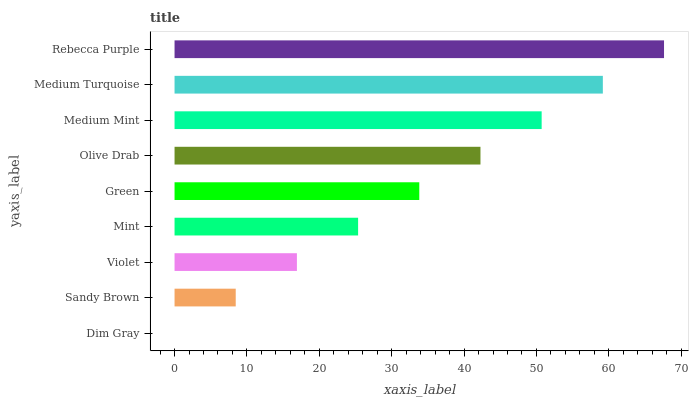Is Dim Gray the minimum?
Answer yes or no. Yes. Is Rebecca Purple the maximum?
Answer yes or no. Yes. Is Sandy Brown the minimum?
Answer yes or no. No. Is Sandy Brown the maximum?
Answer yes or no. No. Is Sandy Brown greater than Dim Gray?
Answer yes or no. Yes. Is Dim Gray less than Sandy Brown?
Answer yes or no. Yes. Is Dim Gray greater than Sandy Brown?
Answer yes or no. No. Is Sandy Brown less than Dim Gray?
Answer yes or no. No. Is Green the high median?
Answer yes or no. Yes. Is Green the low median?
Answer yes or no. Yes. Is Violet the high median?
Answer yes or no. No. Is Medium Turquoise the low median?
Answer yes or no. No. 